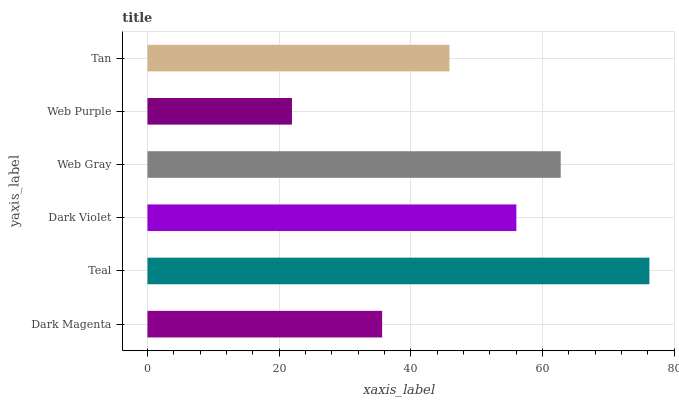Is Web Purple the minimum?
Answer yes or no. Yes. Is Teal the maximum?
Answer yes or no. Yes. Is Dark Violet the minimum?
Answer yes or no. No. Is Dark Violet the maximum?
Answer yes or no. No. Is Teal greater than Dark Violet?
Answer yes or no. Yes. Is Dark Violet less than Teal?
Answer yes or no. Yes. Is Dark Violet greater than Teal?
Answer yes or no. No. Is Teal less than Dark Violet?
Answer yes or no. No. Is Dark Violet the high median?
Answer yes or no. Yes. Is Tan the low median?
Answer yes or no. Yes. Is Web Gray the high median?
Answer yes or no. No. Is Web Purple the low median?
Answer yes or no. No. 